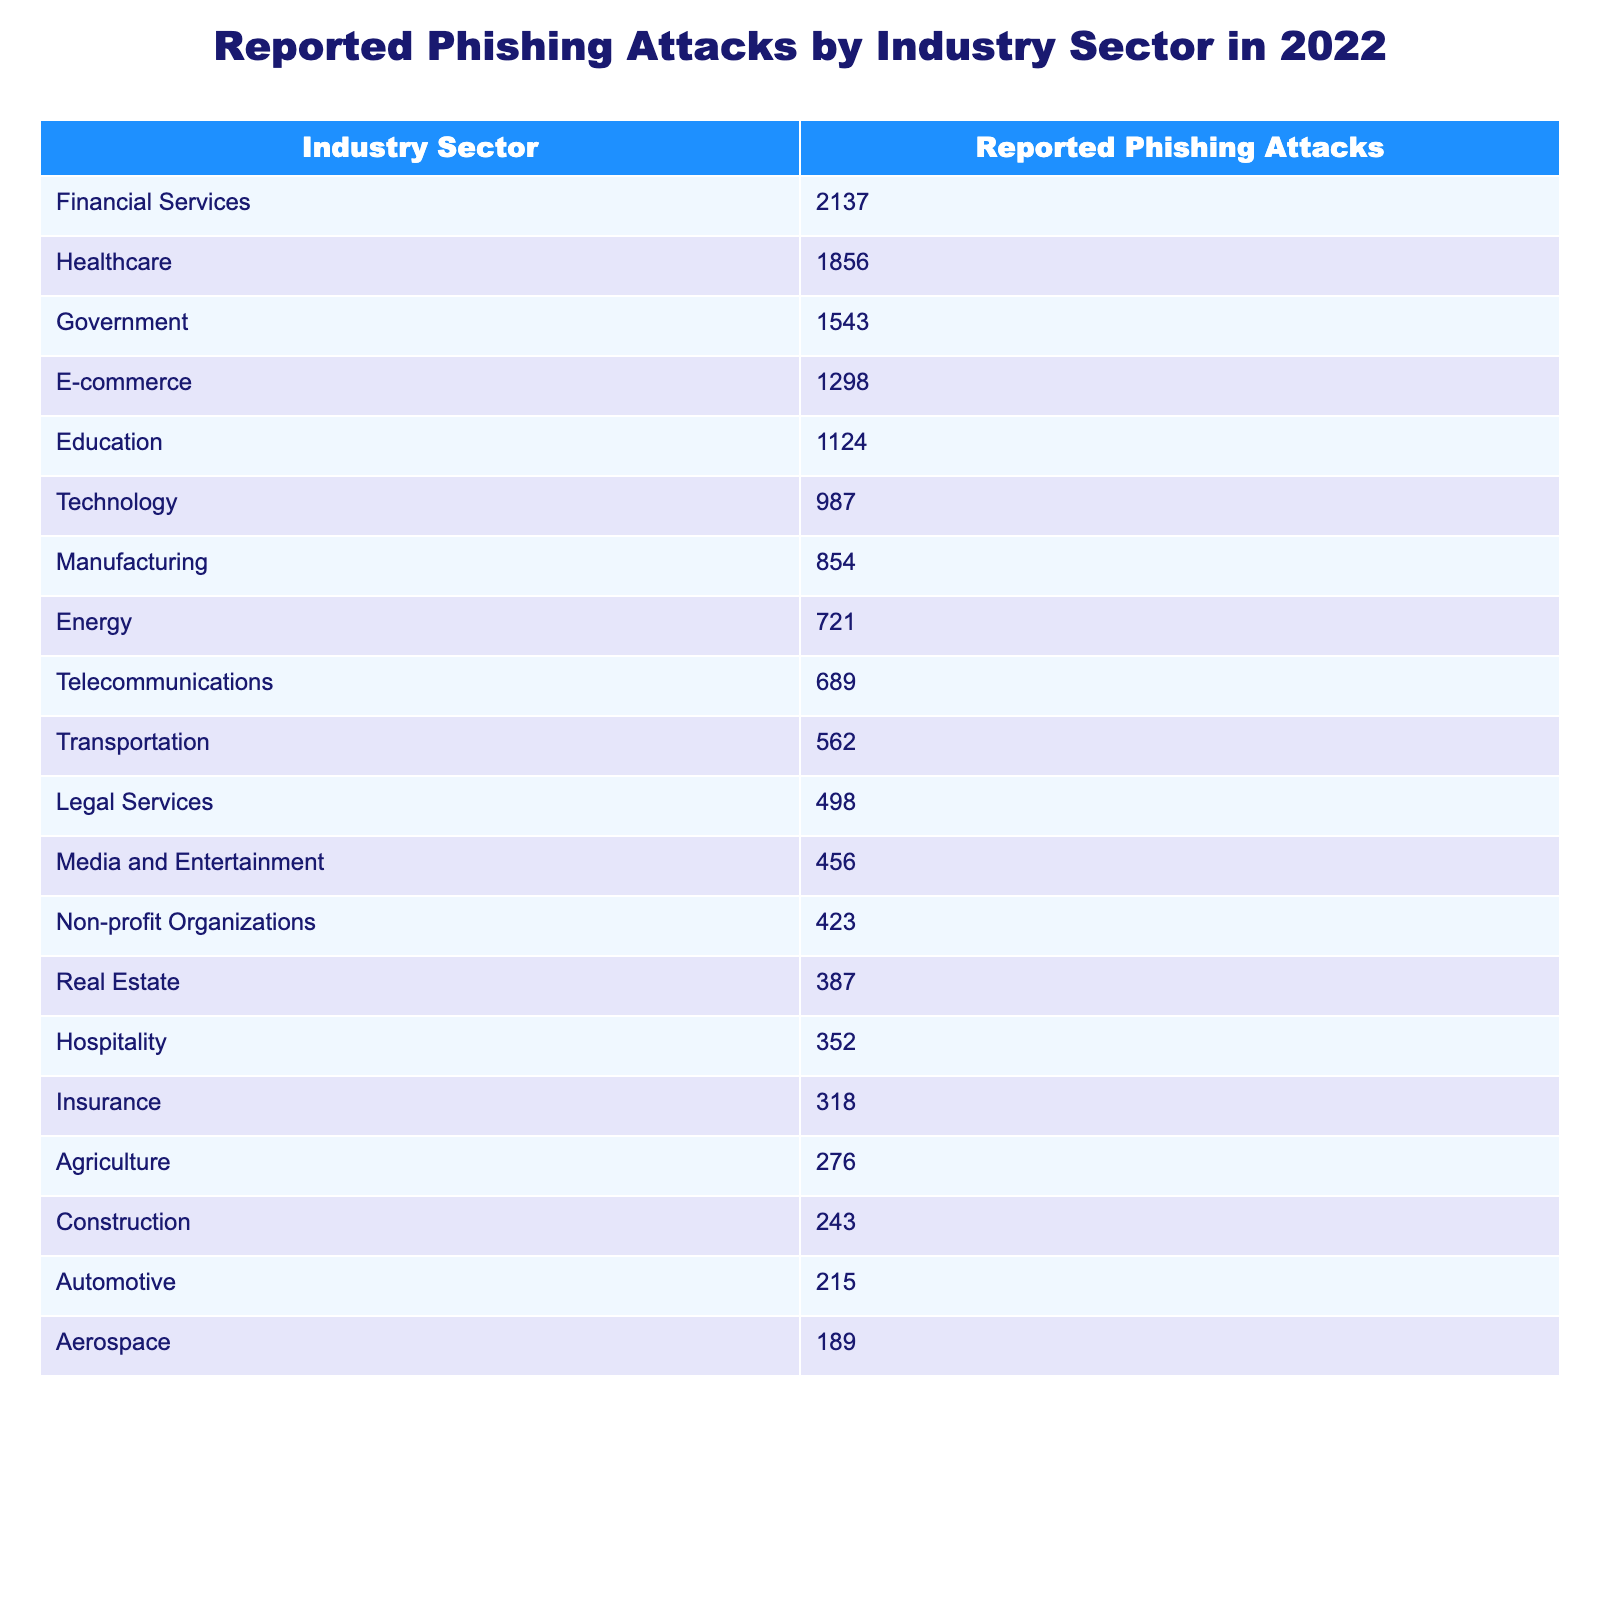What industry sector had the highest number of reported phishing attacks in 2022? Referring to the table, the industry sector labeled "Financial Services" has the highest number of reported phishing attacks listed, with a total of 2137 attacks.
Answer: Financial Services How many reported phishing attacks were there in the healthcare sector? The table shows a specific value for the healthcare sector as 1856 reported phishing attacks.
Answer: 1856 What is the difference in reported phishing attacks between the government and e-commerce sectors? By looking at the numbers, the government sector has 1543 reported phishing attacks while the e-commerce sector has 1298. Calculating the difference: 1543 - 1298 = 245.
Answer: 245 What is the total number of reported phishing attacks across the top three sectors? The top three sectors are Financial Services (2137), Healthcare (1856), and Government (1543). Summing these values: 2137 + 1856 + 1543 = 5536.
Answer: 5536 Is the number of reported phishing attacks in technology greater than the number of attacks in insurance? The table shows 987 attacks in the technology sector and 318 in the insurance sector. Since 987 is greater than 318, the answer is yes.
Answer: Yes What percentage of the total reported phishing attacks in 2022 originated from the agriculture sector? First, sum all reported phishing attacks to get a total. Total = 2137 + 1856 + 1543 + 1298 + 1124 + 987 + 854 + 721 + 689 + 562 + 498 + 456 + 423 + 387 + 352 + 318 + 276 + 243 + 215 + 189 = 13683. The agriculture sector had 276 attacks. The percentage is (276 / 13683) * 100 ≈ 2.02%.
Answer: Approximately 2.02% What is the average number of reported phishing attacks for all the sectors listed? To find the average, first calculate the total number of attacks, which is 13683, then divide by the number of sectors, which is 20 (from the table). Average = 13683 / 20 = 684.15.
Answer: 684.15 Which sector had fewer than 500 reported phishing attacks? In checking the table, both the Legal Services (498), Media and Entertainment (456), Non-profit Organizations (423), Real Estate (387), Hospitality (352), and Insurance (318) sectors had fewer than 500 reported phishing attacks listed.
Answer: Legal Services, Media and Entertainment, Non-profit Organizations, Real Estate, Hospitality, Insurance How many more phishing attacks did the financial services sector report than the healthcare sector? The financial services sector reported 2137 phishing attacks, while the healthcare sector reported 1856. The difference is calculated as 2137 - 1856 = 281.
Answer: 281 Are there more reported phishing attacks in the manufacturing or transportation sector? The table shows 854 attacks in manufacturing and 562 in transportation. Since 854 is greater than 562, manufacturing has more attacks.
Answer: Manufacturing 